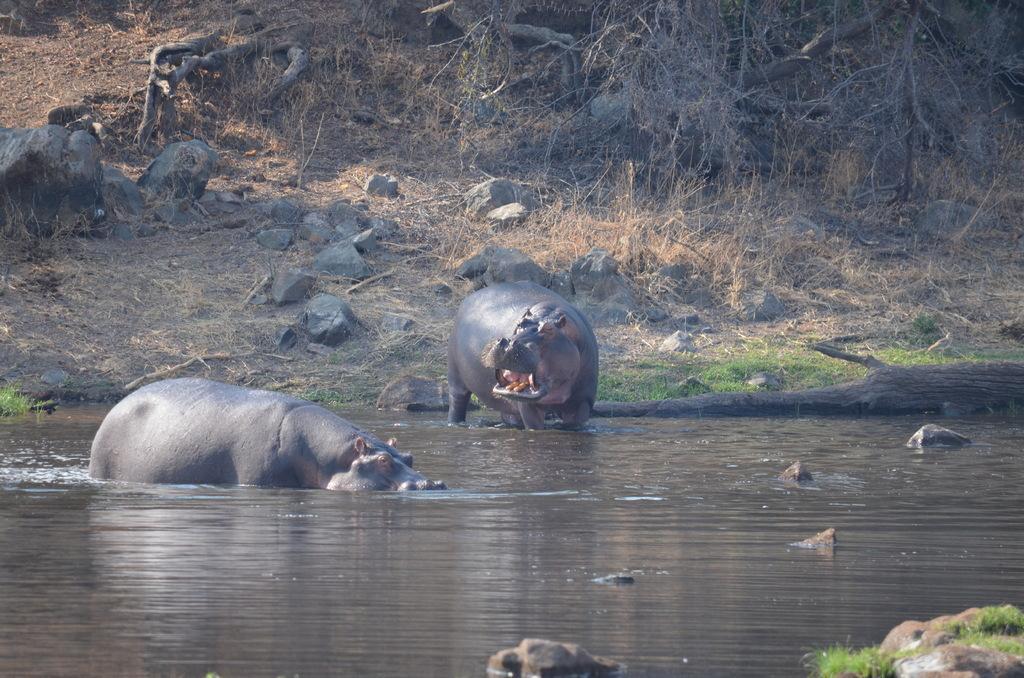How would you summarize this image in a sentence or two? In this image, we can see some animals. We can see some water and some objects floating. We can see the ground. We can see some grass. There are a few roots of the trees. We can see some wood. We can see some stones. 